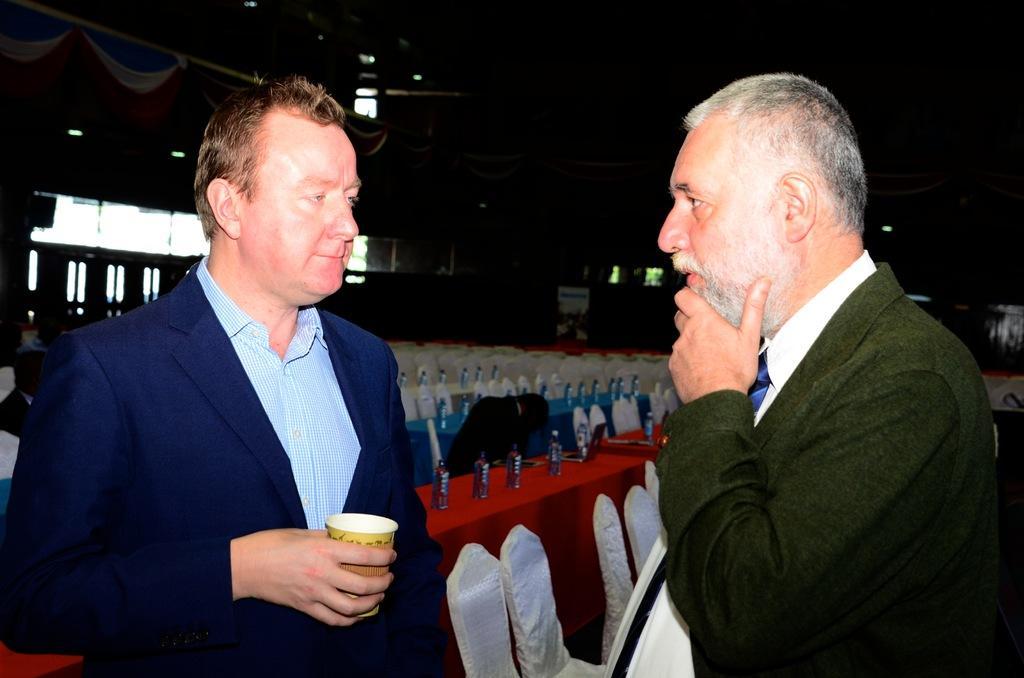How would you summarize this image in a sentence or two? In the front of the image there are two people. Among them one person is holding a cup. In the background of the image there are chairs, tables, curtains, board and objects. On the tables there are bottles.   